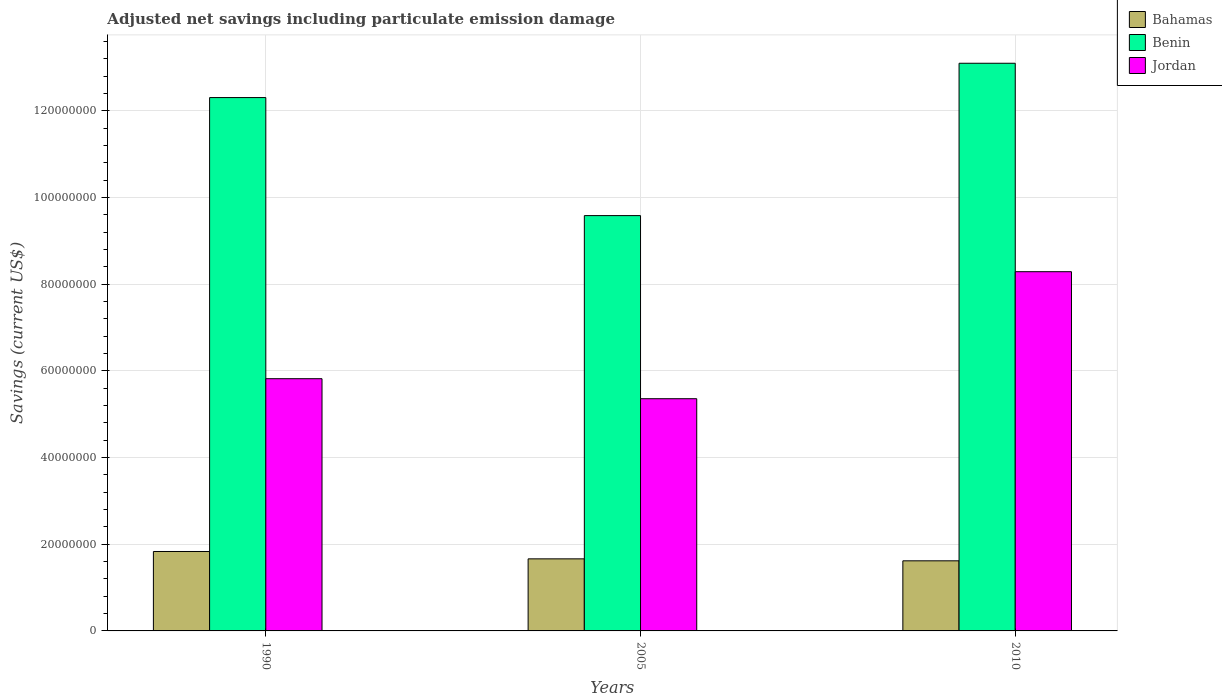Are the number of bars per tick equal to the number of legend labels?
Keep it short and to the point. Yes. Are the number of bars on each tick of the X-axis equal?
Offer a terse response. Yes. In how many cases, is the number of bars for a given year not equal to the number of legend labels?
Keep it short and to the point. 0. What is the net savings in Benin in 2010?
Ensure brevity in your answer.  1.31e+08. Across all years, what is the maximum net savings in Jordan?
Your answer should be compact. 8.29e+07. Across all years, what is the minimum net savings in Benin?
Your answer should be very brief. 9.59e+07. In which year was the net savings in Jordan maximum?
Ensure brevity in your answer.  2010. What is the total net savings in Jordan in the graph?
Your answer should be compact. 1.95e+08. What is the difference between the net savings in Benin in 1990 and that in 2010?
Ensure brevity in your answer.  -7.92e+06. What is the difference between the net savings in Jordan in 2010 and the net savings in Benin in 2005?
Provide a succinct answer. -1.29e+07. What is the average net savings in Jordan per year?
Give a very brief answer. 6.49e+07. In the year 2005, what is the difference between the net savings in Jordan and net savings in Benin?
Make the answer very short. -4.23e+07. What is the ratio of the net savings in Bahamas in 1990 to that in 2010?
Give a very brief answer. 1.13. Is the difference between the net savings in Jordan in 1990 and 2010 greater than the difference between the net savings in Benin in 1990 and 2010?
Provide a short and direct response. No. What is the difference between the highest and the second highest net savings in Jordan?
Your response must be concise. 2.47e+07. What is the difference between the highest and the lowest net savings in Jordan?
Keep it short and to the point. 2.93e+07. In how many years, is the net savings in Jordan greater than the average net savings in Jordan taken over all years?
Your response must be concise. 1. What does the 2nd bar from the left in 2005 represents?
Your response must be concise. Benin. What does the 1st bar from the right in 1990 represents?
Your answer should be very brief. Jordan. Is it the case that in every year, the sum of the net savings in Jordan and net savings in Bahamas is greater than the net savings in Benin?
Make the answer very short. No. How many bars are there?
Keep it short and to the point. 9. Are all the bars in the graph horizontal?
Keep it short and to the point. No. How many years are there in the graph?
Ensure brevity in your answer.  3. What is the difference between two consecutive major ticks on the Y-axis?
Your answer should be very brief. 2.00e+07. Are the values on the major ticks of Y-axis written in scientific E-notation?
Keep it short and to the point. No. Does the graph contain any zero values?
Your answer should be very brief. No. Does the graph contain grids?
Provide a succinct answer. Yes. How many legend labels are there?
Keep it short and to the point. 3. How are the legend labels stacked?
Provide a succinct answer. Vertical. What is the title of the graph?
Your answer should be very brief. Adjusted net savings including particulate emission damage. What is the label or title of the Y-axis?
Make the answer very short. Savings (current US$). What is the Savings (current US$) in Bahamas in 1990?
Give a very brief answer. 1.83e+07. What is the Savings (current US$) of Benin in 1990?
Provide a short and direct response. 1.23e+08. What is the Savings (current US$) of Jordan in 1990?
Give a very brief answer. 5.82e+07. What is the Savings (current US$) in Bahamas in 2005?
Your answer should be very brief. 1.66e+07. What is the Savings (current US$) in Benin in 2005?
Your response must be concise. 9.59e+07. What is the Savings (current US$) of Jordan in 2005?
Keep it short and to the point. 5.36e+07. What is the Savings (current US$) of Bahamas in 2010?
Offer a terse response. 1.62e+07. What is the Savings (current US$) in Benin in 2010?
Make the answer very short. 1.31e+08. What is the Savings (current US$) of Jordan in 2010?
Keep it short and to the point. 8.29e+07. Across all years, what is the maximum Savings (current US$) of Bahamas?
Keep it short and to the point. 1.83e+07. Across all years, what is the maximum Savings (current US$) in Benin?
Offer a terse response. 1.31e+08. Across all years, what is the maximum Savings (current US$) of Jordan?
Ensure brevity in your answer.  8.29e+07. Across all years, what is the minimum Savings (current US$) in Bahamas?
Your answer should be compact. 1.62e+07. Across all years, what is the minimum Savings (current US$) of Benin?
Your response must be concise. 9.59e+07. Across all years, what is the minimum Savings (current US$) of Jordan?
Offer a terse response. 5.36e+07. What is the total Savings (current US$) in Bahamas in the graph?
Keep it short and to the point. 5.11e+07. What is the total Savings (current US$) in Benin in the graph?
Give a very brief answer. 3.50e+08. What is the total Savings (current US$) in Jordan in the graph?
Give a very brief answer. 1.95e+08. What is the difference between the Savings (current US$) in Bahamas in 1990 and that in 2005?
Your answer should be compact. 1.70e+06. What is the difference between the Savings (current US$) of Benin in 1990 and that in 2005?
Give a very brief answer. 2.72e+07. What is the difference between the Savings (current US$) in Jordan in 1990 and that in 2005?
Your answer should be very brief. 4.62e+06. What is the difference between the Savings (current US$) in Bahamas in 1990 and that in 2010?
Offer a terse response. 2.15e+06. What is the difference between the Savings (current US$) in Benin in 1990 and that in 2010?
Your answer should be compact. -7.92e+06. What is the difference between the Savings (current US$) of Jordan in 1990 and that in 2010?
Your answer should be very brief. -2.47e+07. What is the difference between the Savings (current US$) in Bahamas in 2005 and that in 2010?
Provide a short and direct response. 4.55e+05. What is the difference between the Savings (current US$) of Benin in 2005 and that in 2010?
Ensure brevity in your answer.  -3.52e+07. What is the difference between the Savings (current US$) in Jordan in 2005 and that in 2010?
Your answer should be compact. -2.93e+07. What is the difference between the Savings (current US$) in Bahamas in 1990 and the Savings (current US$) in Benin in 2005?
Your response must be concise. -7.75e+07. What is the difference between the Savings (current US$) in Bahamas in 1990 and the Savings (current US$) in Jordan in 2005?
Provide a short and direct response. -3.53e+07. What is the difference between the Savings (current US$) in Benin in 1990 and the Savings (current US$) in Jordan in 2005?
Provide a short and direct response. 6.95e+07. What is the difference between the Savings (current US$) of Bahamas in 1990 and the Savings (current US$) of Benin in 2010?
Offer a terse response. -1.13e+08. What is the difference between the Savings (current US$) in Bahamas in 1990 and the Savings (current US$) in Jordan in 2010?
Give a very brief answer. -6.46e+07. What is the difference between the Savings (current US$) of Benin in 1990 and the Savings (current US$) of Jordan in 2010?
Keep it short and to the point. 4.02e+07. What is the difference between the Savings (current US$) in Bahamas in 2005 and the Savings (current US$) in Benin in 2010?
Offer a very short reply. -1.14e+08. What is the difference between the Savings (current US$) in Bahamas in 2005 and the Savings (current US$) in Jordan in 2010?
Provide a succinct answer. -6.63e+07. What is the difference between the Savings (current US$) of Benin in 2005 and the Savings (current US$) of Jordan in 2010?
Offer a very short reply. 1.29e+07. What is the average Savings (current US$) in Bahamas per year?
Keep it short and to the point. 1.70e+07. What is the average Savings (current US$) in Benin per year?
Provide a succinct answer. 1.17e+08. What is the average Savings (current US$) of Jordan per year?
Offer a very short reply. 6.49e+07. In the year 1990, what is the difference between the Savings (current US$) of Bahamas and Savings (current US$) of Benin?
Provide a succinct answer. -1.05e+08. In the year 1990, what is the difference between the Savings (current US$) of Bahamas and Savings (current US$) of Jordan?
Your response must be concise. -3.99e+07. In the year 1990, what is the difference between the Savings (current US$) in Benin and Savings (current US$) in Jordan?
Your answer should be very brief. 6.49e+07. In the year 2005, what is the difference between the Savings (current US$) of Bahamas and Savings (current US$) of Benin?
Your response must be concise. -7.92e+07. In the year 2005, what is the difference between the Savings (current US$) of Bahamas and Savings (current US$) of Jordan?
Your response must be concise. -3.70e+07. In the year 2005, what is the difference between the Savings (current US$) in Benin and Savings (current US$) in Jordan?
Make the answer very short. 4.23e+07. In the year 2010, what is the difference between the Savings (current US$) of Bahamas and Savings (current US$) of Benin?
Provide a succinct answer. -1.15e+08. In the year 2010, what is the difference between the Savings (current US$) in Bahamas and Savings (current US$) in Jordan?
Your answer should be compact. -6.67e+07. In the year 2010, what is the difference between the Savings (current US$) of Benin and Savings (current US$) of Jordan?
Ensure brevity in your answer.  4.81e+07. What is the ratio of the Savings (current US$) of Bahamas in 1990 to that in 2005?
Provide a short and direct response. 1.1. What is the ratio of the Savings (current US$) of Benin in 1990 to that in 2005?
Your answer should be very brief. 1.28. What is the ratio of the Savings (current US$) of Jordan in 1990 to that in 2005?
Your response must be concise. 1.09. What is the ratio of the Savings (current US$) in Bahamas in 1990 to that in 2010?
Keep it short and to the point. 1.13. What is the ratio of the Savings (current US$) in Benin in 1990 to that in 2010?
Provide a succinct answer. 0.94. What is the ratio of the Savings (current US$) of Jordan in 1990 to that in 2010?
Give a very brief answer. 0.7. What is the ratio of the Savings (current US$) in Bahamas in 2005 to that in 2010?
Your answer should be compact. 1.03. What is the ratio of the Savings (current US$) in Benin in 2005 to that in 2010?
Your response must be concise. 0.73. What is the ratio of the Savings (current US$) of Jordan in 2005 to that in 2010?
Provide a succinct answer. 0.65. What is the difference between the highest and the second highest Savings (current US$) in Bahamas?
Keep it short and to the point. 1.70e+06. What is the difference between the highest and the second highest Savings (current US$) in Benin?
Ensure brevity in your answer.  7.92e+06. What is the difference between the highest and the second highest Savings (current US$) of Jordan?
Your answer should be compact. 2.47e+07. What is the difference between the highest and the lowest Savings (current US$) in Bahamas?
Make the answer very short. 2.15e+06. What is the difference between the highest and the lowest Savings (current US$) in Benin?
Offer a terse response. 3.52e+07. What is the difference between the highest and the lowest Savings (current US$) of Jordan?
Keep it short and to the point. 2.93e+07. 